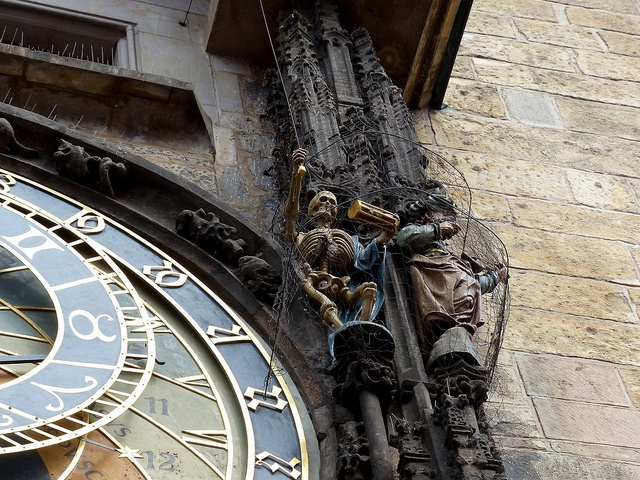Describe the objects in this image and their specific colors. I can see a clock in black, white, darkgray, and lightblue tones in this image. 